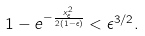Convert formula to latex. <formula><loc_0><loc_0><loc_500><loc_500>1 - e ^ { - \frac { x _ { \epsilon } ^ { 2 } } { 2 ( 1 - \epsilon ) } } < \epsilon ^ { 3 / 2 } .</formula> 